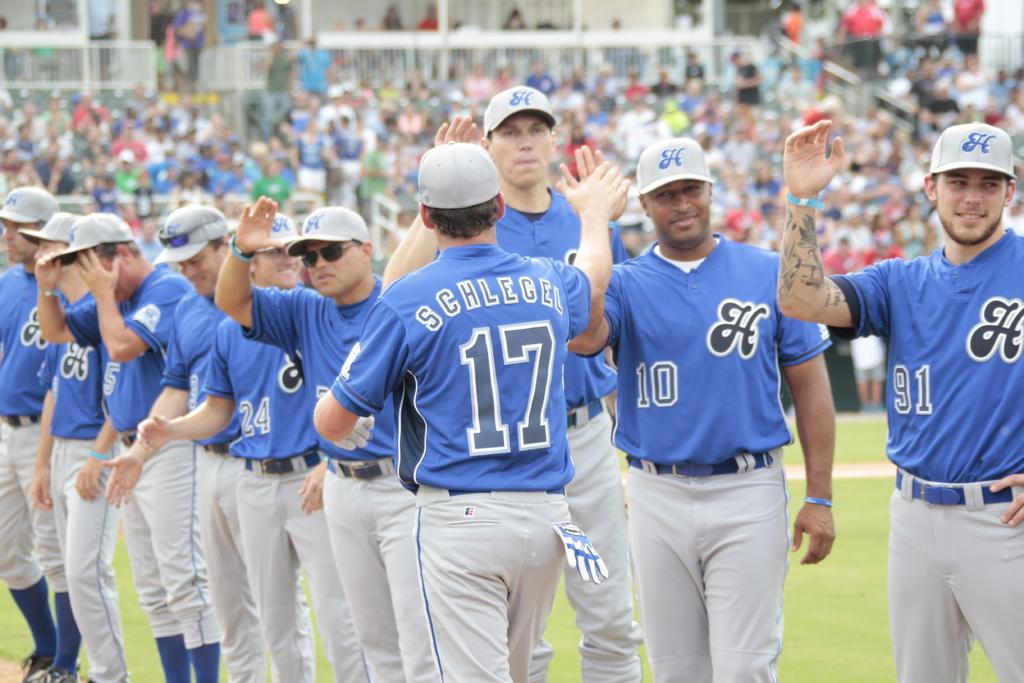<image>
Give a short and clear explanation of the subsequent image. A man in a baseball uniform with the number 17 on it is on a field with other players. 